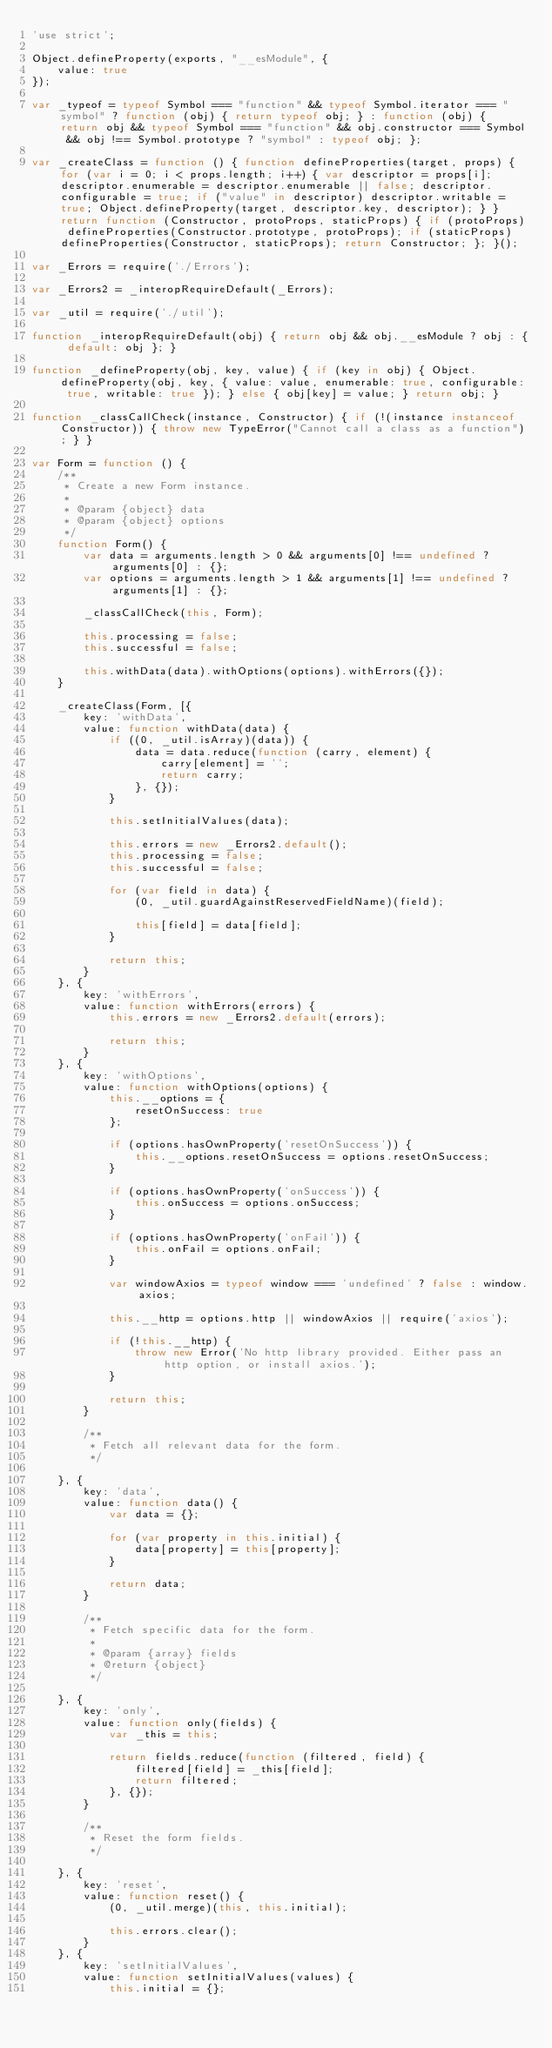Convert code to text. <code><loc_0><loc_0><loc_500><loc_500><_JavaScript_>'use strict';

Object.defineProperty(exports, "__esModule", {
    value: true
});

var _typeof = typeof Symbol === "function" && typeof Symbol.iterator === "symbol" ? function (obj) { return typeof obj; } : function (obj) { return obj && typeof Symbol === "function" && obj.constructor === Symbol && obj !== Symbol.prototype ? "symbol" : typeof obj; };

var _createClass = function () { function defineProperties(target, props) { for (var i = 0; i < props.length; i++) { var descriptor = props[i]; descriptor.enumerable = descriptor.enumerable || false; descriptor.configurable = true; if ("value" in descriptor) descriptor.writable = true; Object.defineProperty(target, descriptor.key, descriptor); } } return function (Constructor, protoProps, staticProps) { if (protoProps) defineProperties(Constructor.prototype, protoProps); if (staticProps) defineProperties(Constructor, staticProps); return Constructor; }; }();

var _Errors = require('./Errors');

var _Errors2 = _interopRequireDefault(_Errors);

var _util = require('./util');

function _interopRequireDefault(obj) { return obj && obj.__esModule ? obj : { default: obj }; }

function _defineProperty(obj, key, value) { if (key in obj) { Object.defineProperty(obj, key, { value: value, enumerable: true, configurable: true, writable: true }); } else { obj[key] = value; } return obj; }

function _classCallCheck(instance, Constructor) { if (!(instance instanceof Constructor)) { throw new TypeError("Cannot call a class as a function"); } }

var Form = function () {
    /**
     * Create a new Form instance.
     *
     * @param {object} data
     * @param {object} options
     */
    function Form() {
        var data = arguments.length > 0 && arguments[0] !== undefined ? arguments[0] : {};
        var options = arguments.length > 1 && arguments[1] !== undefined ? arguments[1] : {};

        _classCallCheck(this, Form);

        this.processing = false;
        this.successful = false;

        this.withData(data).withOptions(options).withErrors({});
    }

    _createClass(Form, [{
        key: 'withData',
        value: function withData(data) {
            if ((0, _util.isArray)(data)) {
                data = data.reduce(function (carry, element) {
                    carry[element] = '';
                    return carry;
                }, {});
            }

            this.setInitialValues(data);

            this.errors = new _Errors2.default();
            this.processing = false;
            this.successful = false;

            for (var field in data) {
                (0, _util.guardAgainstReservedFieldName)(field);

                this[field] = data[field];
            }

            return this;
        }
    }, {
        key: 'withErrors',
        value: function withErrors(errors) {
            this.errors = new _Errors2.default(errors);

            return this;
        }
    }, {
        key: 'withOptions',
        value: function withOptions(options) {
            this.__options = {
                resetOnSuccess: true
            };

            if (options.hasOwnProperty('resetOnSuccess')) {
                this.__options.resetOnSuccess = options.resetOnSuccess;
            }

            if (options.hasOwnProperty('onSuccess')) {
                this.onSuccess = options.onSuccess;
            }

            if (options.hasOwnProperty('onFail')) {
                this.onFail = options.onFail;
            }

            var windowAxios = typeof window === 'undefined' ? false : window.axios;

            this.__http = options.http || windowAxios || require('axios');

            if (!this.__http) {
                throw new Error('No http library provided. Either pass an http option, or install axios.');
            }

            return this;
        }

        /**
         * Fetch all relevant data for the form.
         */

    }, {
        key: 'data',
        value: function data() {
            var data = {};

            for (var property in this.initial) {
                data[property] = this[property];
            }

            return data;
        }

        /**
         * Fetch specific data for the form.
         *
         * @param {array} fields
         * @return {object}
         */

    }, {
        key: 'only',
        value: function only(fields) {
            var _this = this;

            return fields.reduce(function (filtered, field) {
                filtered[field] = _this[field];
                return filtered;
            }, {});
        }

        /**
         * Reset the form fields.
         */

    }, {
        key: 'reset',
        value: function reset() {
            (0, _util.merge)(this, this.initial);

            this.errors.clear();
        }
    }, {
        key: 'setInitialValues',
        value: function setInitialValues(values) {
            this.initial = {};
</code> 